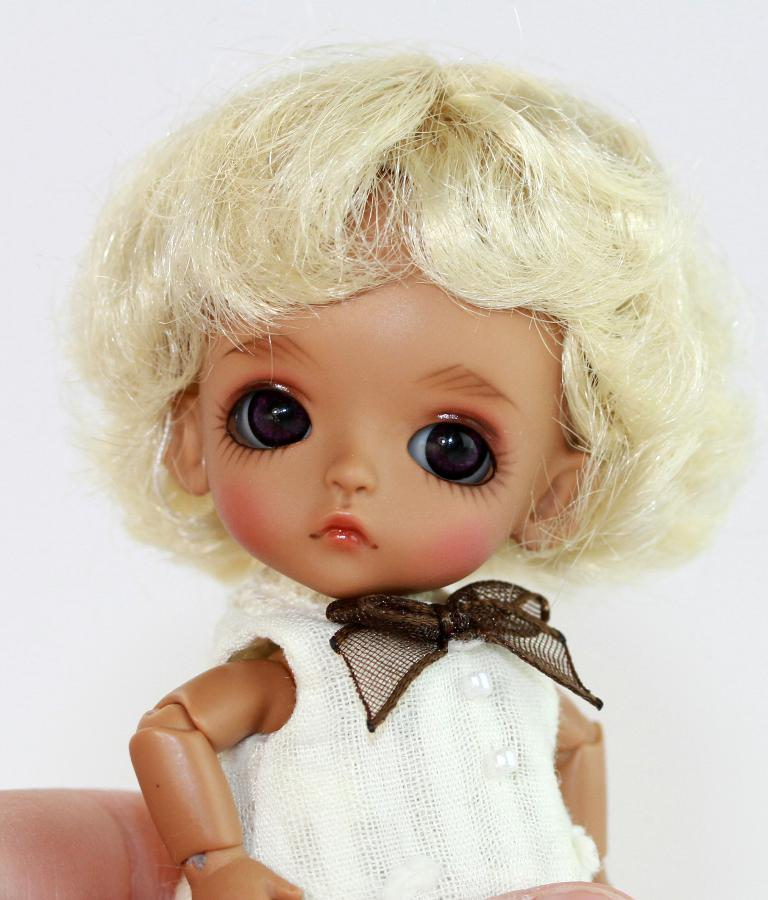What is the main subject of the image? There is a doll in the image. Can you describe the background of the image? There is a wall visible in the background of the image. What type of discussion is taking place in the image? There is no discussion taking place in the image, as it only features a doll and a wall in the background. 